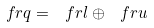Convert formula to latex. <formula><loc_0><loc_0><loc_500><loc_500>\ f r q = \ f r l \oplus \ f r u</formula> 